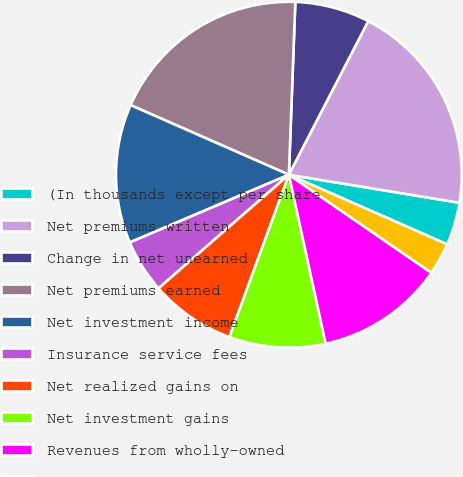Convert chart to OTSL. <chart><loc_0><loc_0><loc_500><loc_500><pie_chart><fcel>(In thousands except per share<fcel>Net premiums written<fcel>Change in net unearned<fcel>Net premiums earned<fcel>Net investment income<fcel>Insurance service fees<fcel>Net realized gains on<fcel>Net investment gains<fcel>Revenues from wholly-owned<fcel>Other income<nl><fcel>4.0%<fcel>20.0%<fcel>7.0%<fcel>19.0%<fcel>13.0%<fcel>5.0%<fcel>8.0%<fcel>9.0%<fcel>12.0%<fcel>3.0%<nl></chart> 